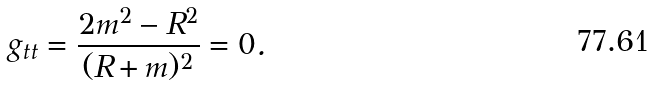<formula> <loc_0><loc_0><loc_500><loc_500>g _ { t t } = \frac { 2 m ^ { 2 } - R ^ { 2 } } { ( R + m ) ^ { 2 } } = 0 .</formula> 